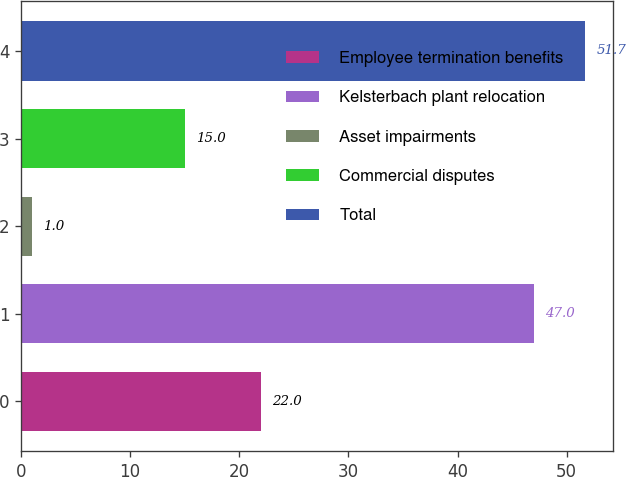Convert chart to OTSL. <chart><loc_0><loc_0><loc_500><loc_500><bar_chart><fcel>Employee termination benefits<fcel>Kelsterbach plant relocation<fcel>Asset impairments<fcel>Commercial disputes<fcel>Total<nl><fcel>22<fcel>47<fcel>1<fcel>15<fcel>51.7<nl></chart> 